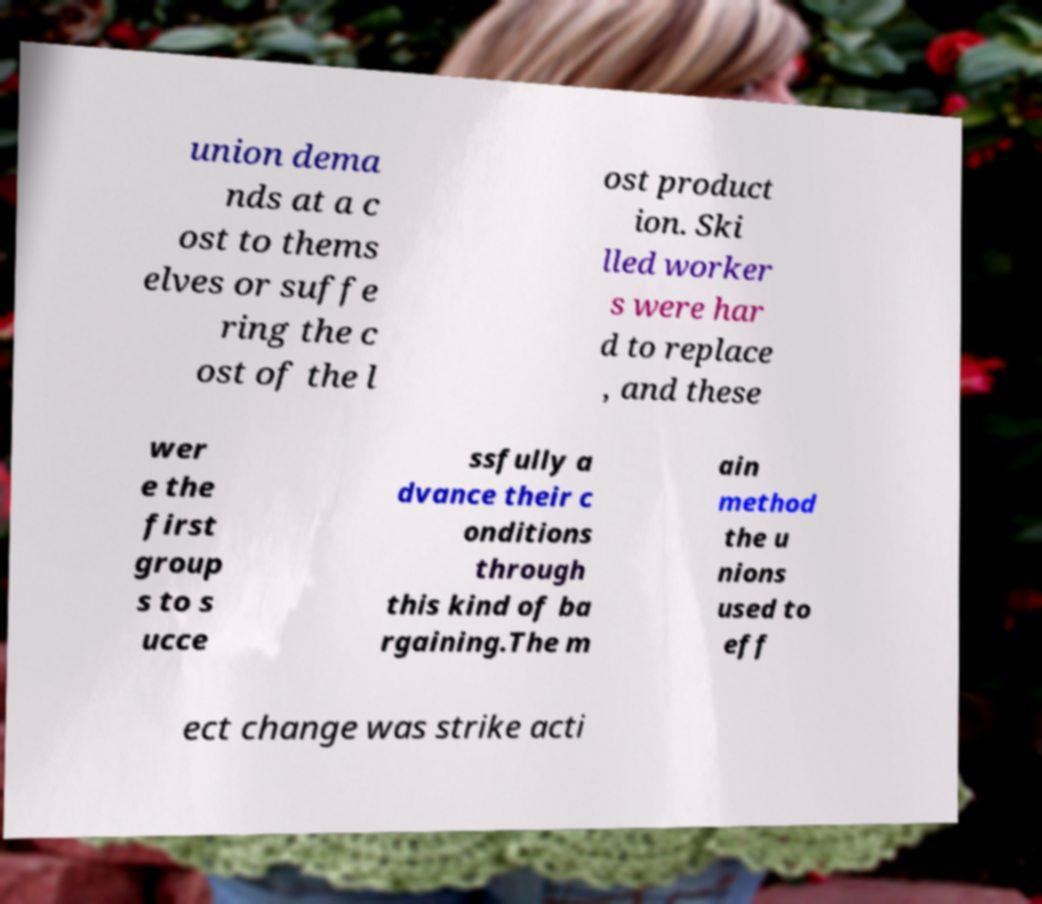I need the written content from this picture converted into text. Can you do that? union dema nds at a c ost to thems elves or suffe ring the c ost of the l ost product ion. Ski lled worker s were har d to replace , and these wer e the first group s to s ucce ssfully a dvance their c onditions through this kind of ba rgaining.The m ain method the u nions used to eff ect change was strike acti 